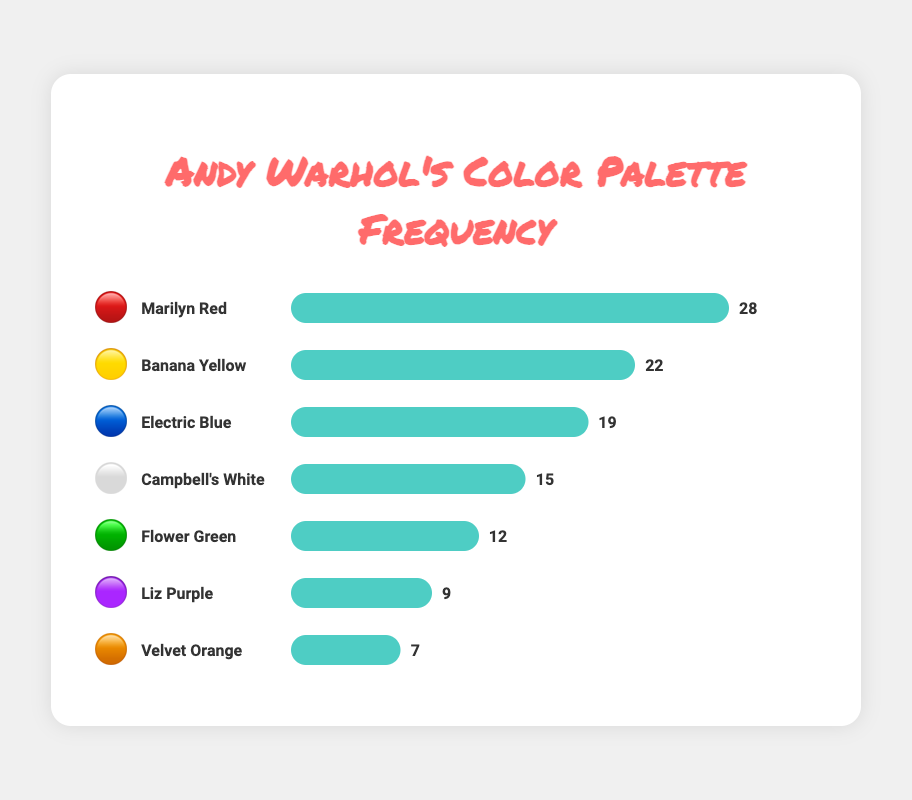What's the most frequent color in Andy Warhol's palette? The figure shows the frequency of different colors represented by emoji swatches. The color with the highest frequency is represented by the longest bar. "Marilyn Red" 🔴 has the highest frequency of 28.
Answer: Marilyn Red (🔴) What's the combined frequency of "Flower Green" and "Liz Purple"? The frequency of "Flower Green" is 12, and "Liz Purple" is 9. Adding these together gives 12 + 9 = 21.
Answer: 21 How many colors have a frequency greater than 20? By looking at the figure, the colors with frequencies greater than 20 are "Marilyn Red" (28) and "Banana Yellow" (22). That's 2 colors.
Answer: 2 What color has the lowest frequency? The color with the shortest bar in the figure is "Velvet Orange" 🟠, with a frequency of 7.
Answer: Velvet Orange (🟠) Is "Campbell's White" more frequent than "Flower Green"? By comparing the bars, "Campbell's White" (15) has a higher frequency than "Flower Green" (12).
Answer: Yes What is the difference in frequency between "Electric Blue" and "Liz Purple"? The frequency of "Electric Blue" is 19, and "Liz Purple" is 9. The difference is 19 - 9 = 10.
Answer: 10 What percentage of the total frequency is represented by "Banana Yellow"? The total frequency is 28 + 22 + 19 + 15 + 12 + 9 + 7 = 112. "Banana Yellow" has a frequency of 22. The percentage is (22/112) * 100 ≈ 19.64%.
Answer: Approximately 19.64% Which color is more frequent, "Electric Blue" or "Campbell's White"? By comparing the bars, "Electric Blue" (19) has a higher frequency than "Campbell's White" (15).
Answer: Electric Blue (🔵) What is the median frequency of the colors? To find the median, list the frequencies in order: 7, 9, 12, 15, 19, 22, 28. The median is the middle number, which is 15.
Answer: 15 